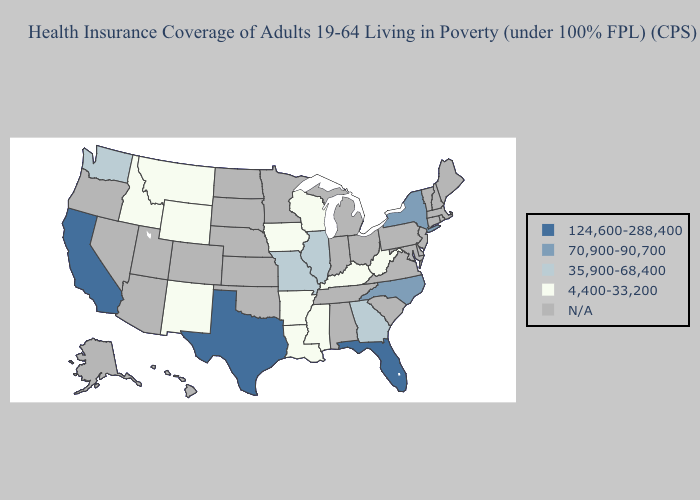Name the states that have a value in the range 70,900-90,700?
Answer briefly. New York, North Carolina. Does Missouri have the lowest value in the MidWest?
Be succinct. No. Name the states that have a value in the range N/A?
Quick response, please. Alabama, Alaska, Arizona, Colorado, Connecticut, Delaware, Hawaii, Indiana, Kansas, Maine, Maryland, Massachusetts, Michigan, Minnesota, Nebraska, Nevada, New Hampshire, New Jersey, North Dakota, Ohio, Oklahoma, Oregon, Pennsylvania, Rhode Island, South Carolina, South Dakota, Tennessee, Utah, Vermont, Virginia. Name the states that have a value in the range N/A?
Keep it brief. Alabama, Alaska, Arizona, Colorado, Connecticut, Delaware, Hawaii, Indiana, Kansas, Maine, Maryland, Massachusetts, Michigan, Minnesota, Nebraska, Nevada, New Hampshire, New Jersey, North Dakota, Ohio, Oklahoma, Oregon, Pennsylvania, Rhode Island, South Carolina, South Dakota, Tennessee, Utah, Vermont, Virginia. What is the highest value in the Northeast ?
Give a very brief answer. 70,900-90,700. Does California have the lowest value in the USA?
Be succinct. No. Which states have the lowest value in the USA?
Be succinct. Arkansas, Idaho, Iowa, Kentucky, Louisiana, Mississippi, Montana, New Mexico, West Virginia, Wisconsin, Wyoming. Does California have the highest value in the West?
Answer briefly. Yes. Among the states that border Louisiana , which have the lowest value?
Quick response, please. Arkansas, Mississippi. What is the value of Louisiana?
Write a very short answer. 4,400-33,200. Does Texas have the highest value in the USA?
Short answer required. Yes. Among the states that border Oregon , which have the lowest value?
Short answer required. Idaho. 